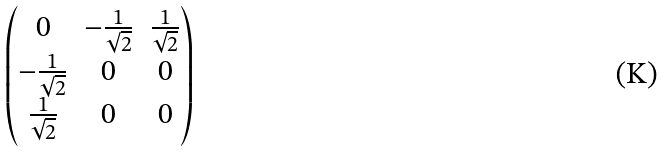Convert formula to latex. <formula><loc_0><loc_0><loc_500><loc_500>\begin{pmatrix} 0 & - \frac { 1 } { \sqrt { 2 } } & \frac { 1 } { \sqrt { 2 } } \\ - \frac { 1 } { \sqrt { 2 } } & 0 & 0 \\ \frac { 1 } { \sqrt { 2 } } & 0 & 0 \end{pmatrix}</formula> 